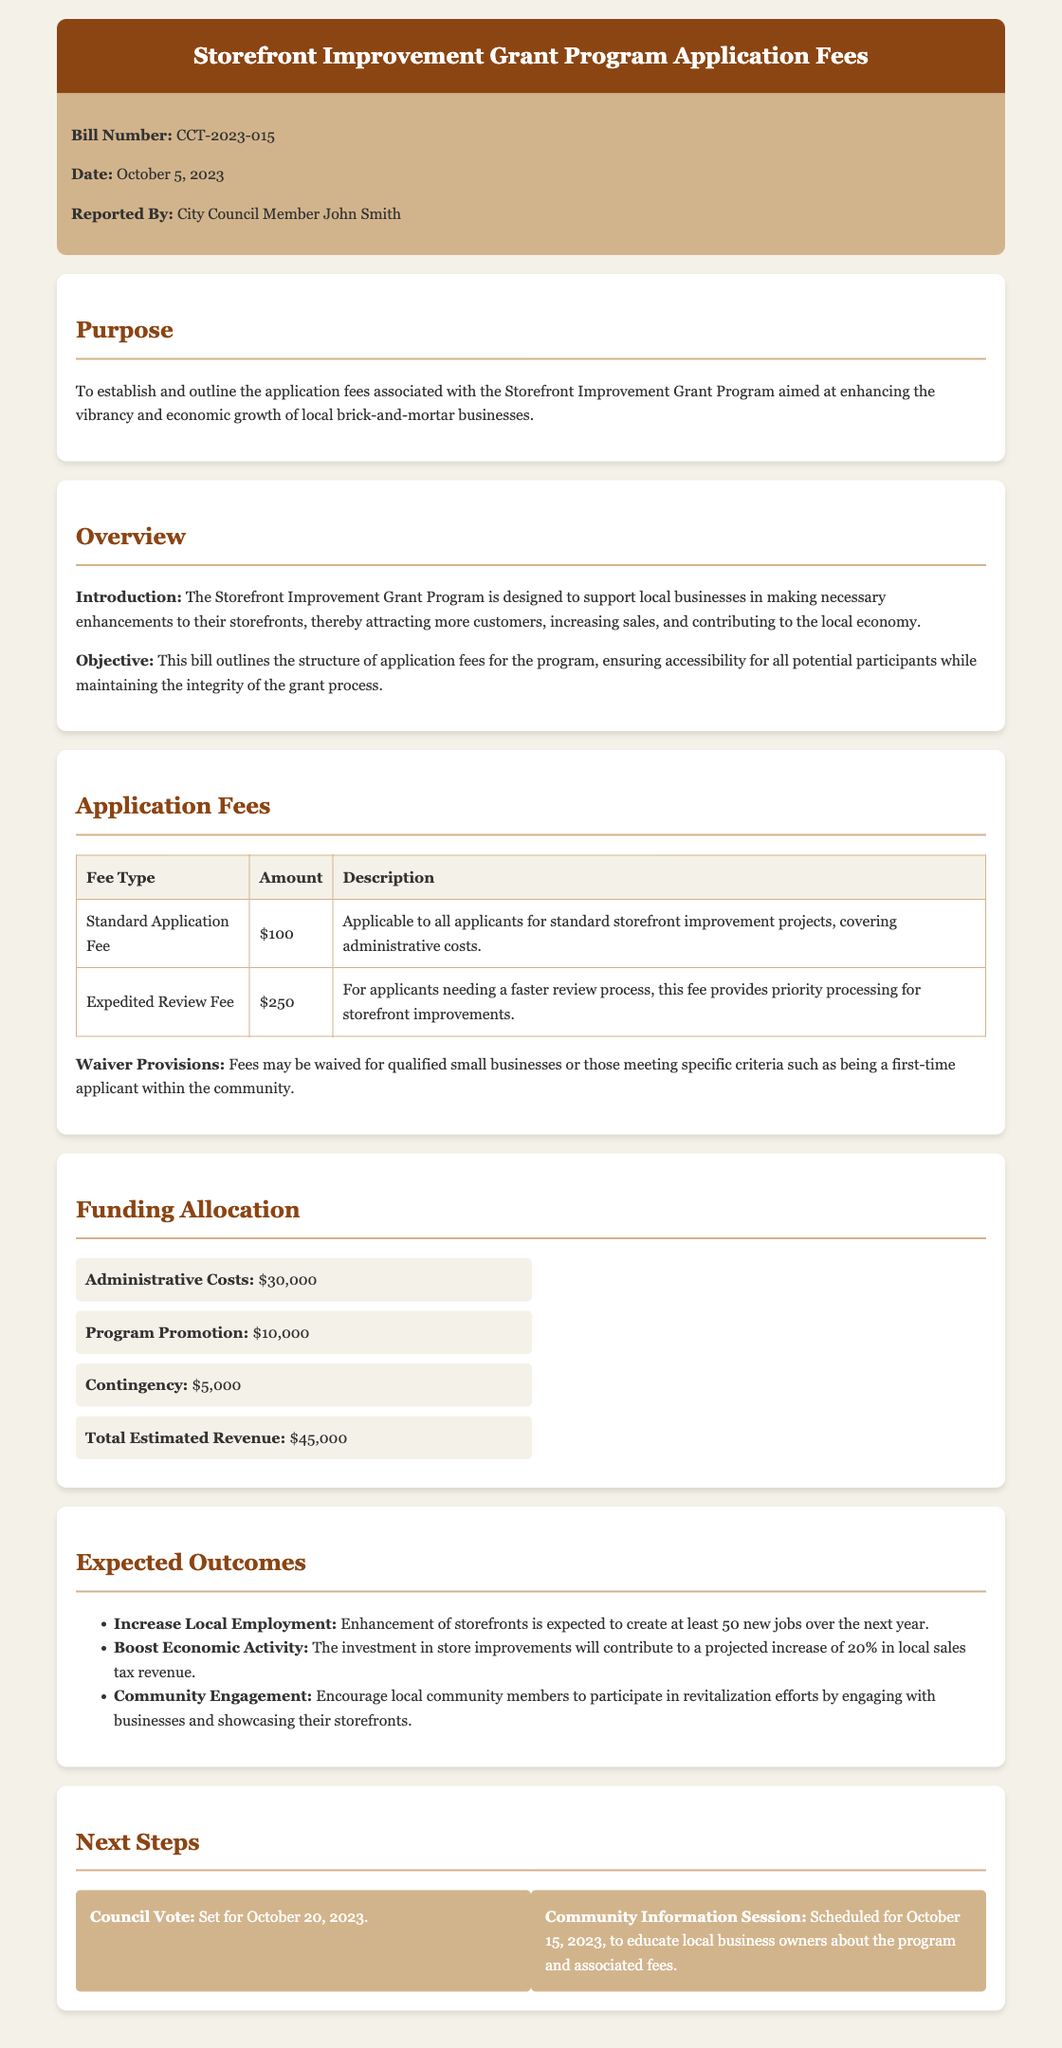What is the bill number? The bill number is listed in the document under the bill info section.
Answer: CCT-2023-015 What is the standard application fee? The standard application fee is mentioned in the application fees section of the document.
Answer: $100 What is the expected increase in local sales tax revenue? The expected increase in local sales tax revenue is specified in the expected outcomes section.
Answer: 20% When is the council vote scheduled? The date for the council vote is explicitly stated in the next steps section.
Answer: October 20, 2023 What are the qualifications for fee waivers? The waivers are mentioned in the application fees section detail criteria like small businesses or first-time applicants.
Answer: Qualified small businesses or first-time applicants How much is allocated for program promotion? The amount for program promotion is detailed in the funding allocation section.
Answer: $10,000 What is the objective of this bill? The objective is summarized in the overview section of the document.
Answer: Ensure accessibility for all potential participants What is the total estimated revenue? The total estimated revenue is provided in the funding allocation section.
Answer: $45,000 